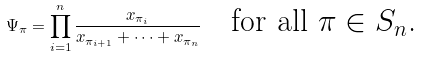Convert formula to latex. <formula><loc_0><loc_0><loc_500><loc_500>\Psi _ { \pi } = \prod _ { i = 1 } ^ { n } \frac { x _ { \pi _ { i } } } { x _ { \pi _ { i + 1 } } + \cdots + x _ { \pi _ { n } } } \quad \text {for all $\pi \in S_{n}$.}</formula> 